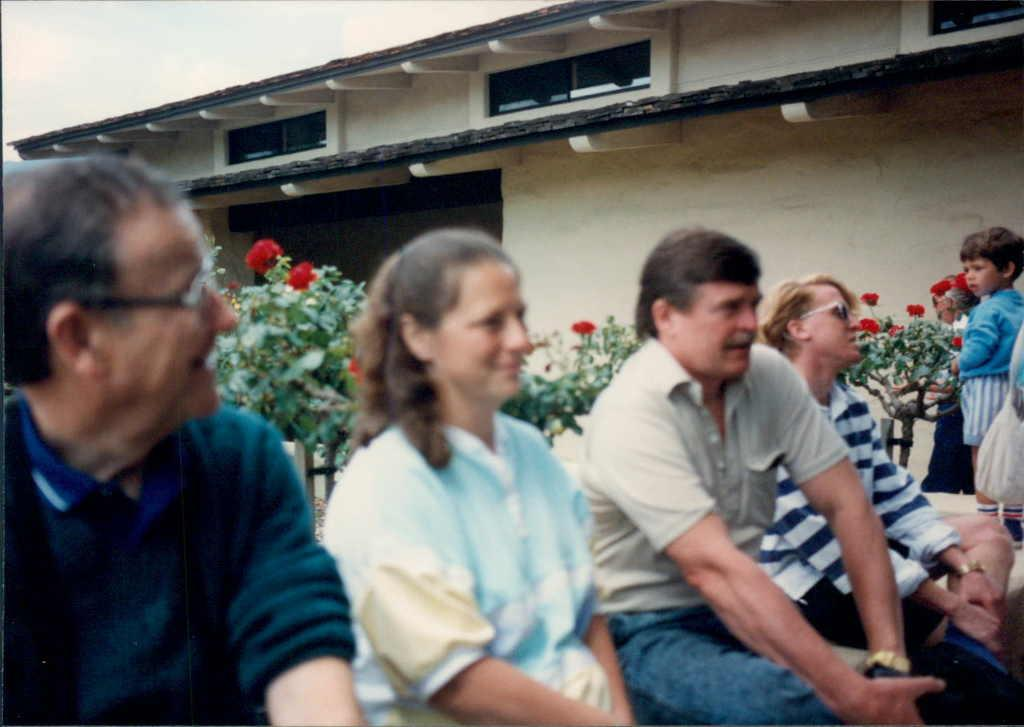What are the people in the image doing? The people in the image are sitting. How are the people arranged in the image? The people are sitting one after the other. What can be seen on the right side of the image? There is a child standing on the right side of the image. What type of jelly is being served during the meal in the image? There is no meal or jelly present in the image; it only shows people sitting and a child standing. 